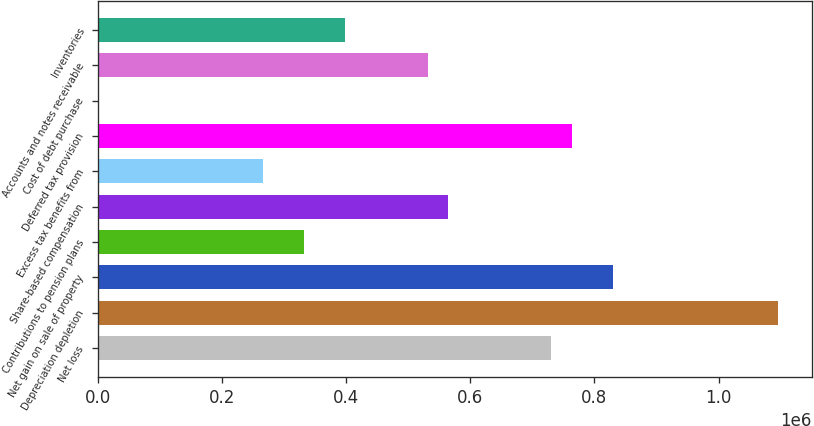<chart> <loc_0><loc_0><loc_500><loc_500><bar_chart><fcel>Net loss<fcel>Depreciation depletion<fcel>Net gain on sale of property<fcel>Contributions to pension plans<fcel>Share-based compensation<fcel>Excess tax benefits from<fcel>Deferred tax provision<fcel>Cost of debt purchase<fcel>Accounts and notes receivable<fcel>Inventories<nl><fcel>730309<fcel>1.09546e+06<fcel>829897<fcel>331959<fcel>564330<fcel>265567<fcel>763505<fcel>0.51<fcel>531134<fcel>398351<nl></chart> 